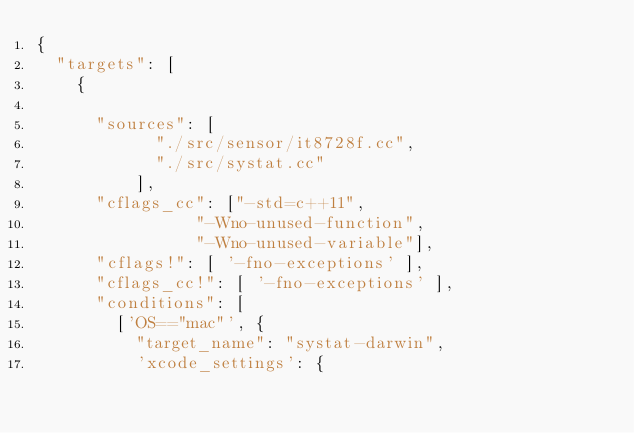Convert code to text. <code><loc_0><loc_0><loc_500><loc_500><_Python_>{
  "targets": [
    {
      
      "sources": [           
            "./src/sensor/it8728f.cc",         
            "./src/systat.cc"
          ],
      "cflags_cc": ["-std=c++11",
				"-Wno-unused-function",
				"-Wno-unused-variable"],
      "cflags!": [ '-fno-exceptions' ],
      "cflags_cc!": [ '-fno-exceptions' ],
      "conditions": [
        ['OS=="mac"', {
          "target_name": "systat-darwin",
          'xcode_settings': {</code> 